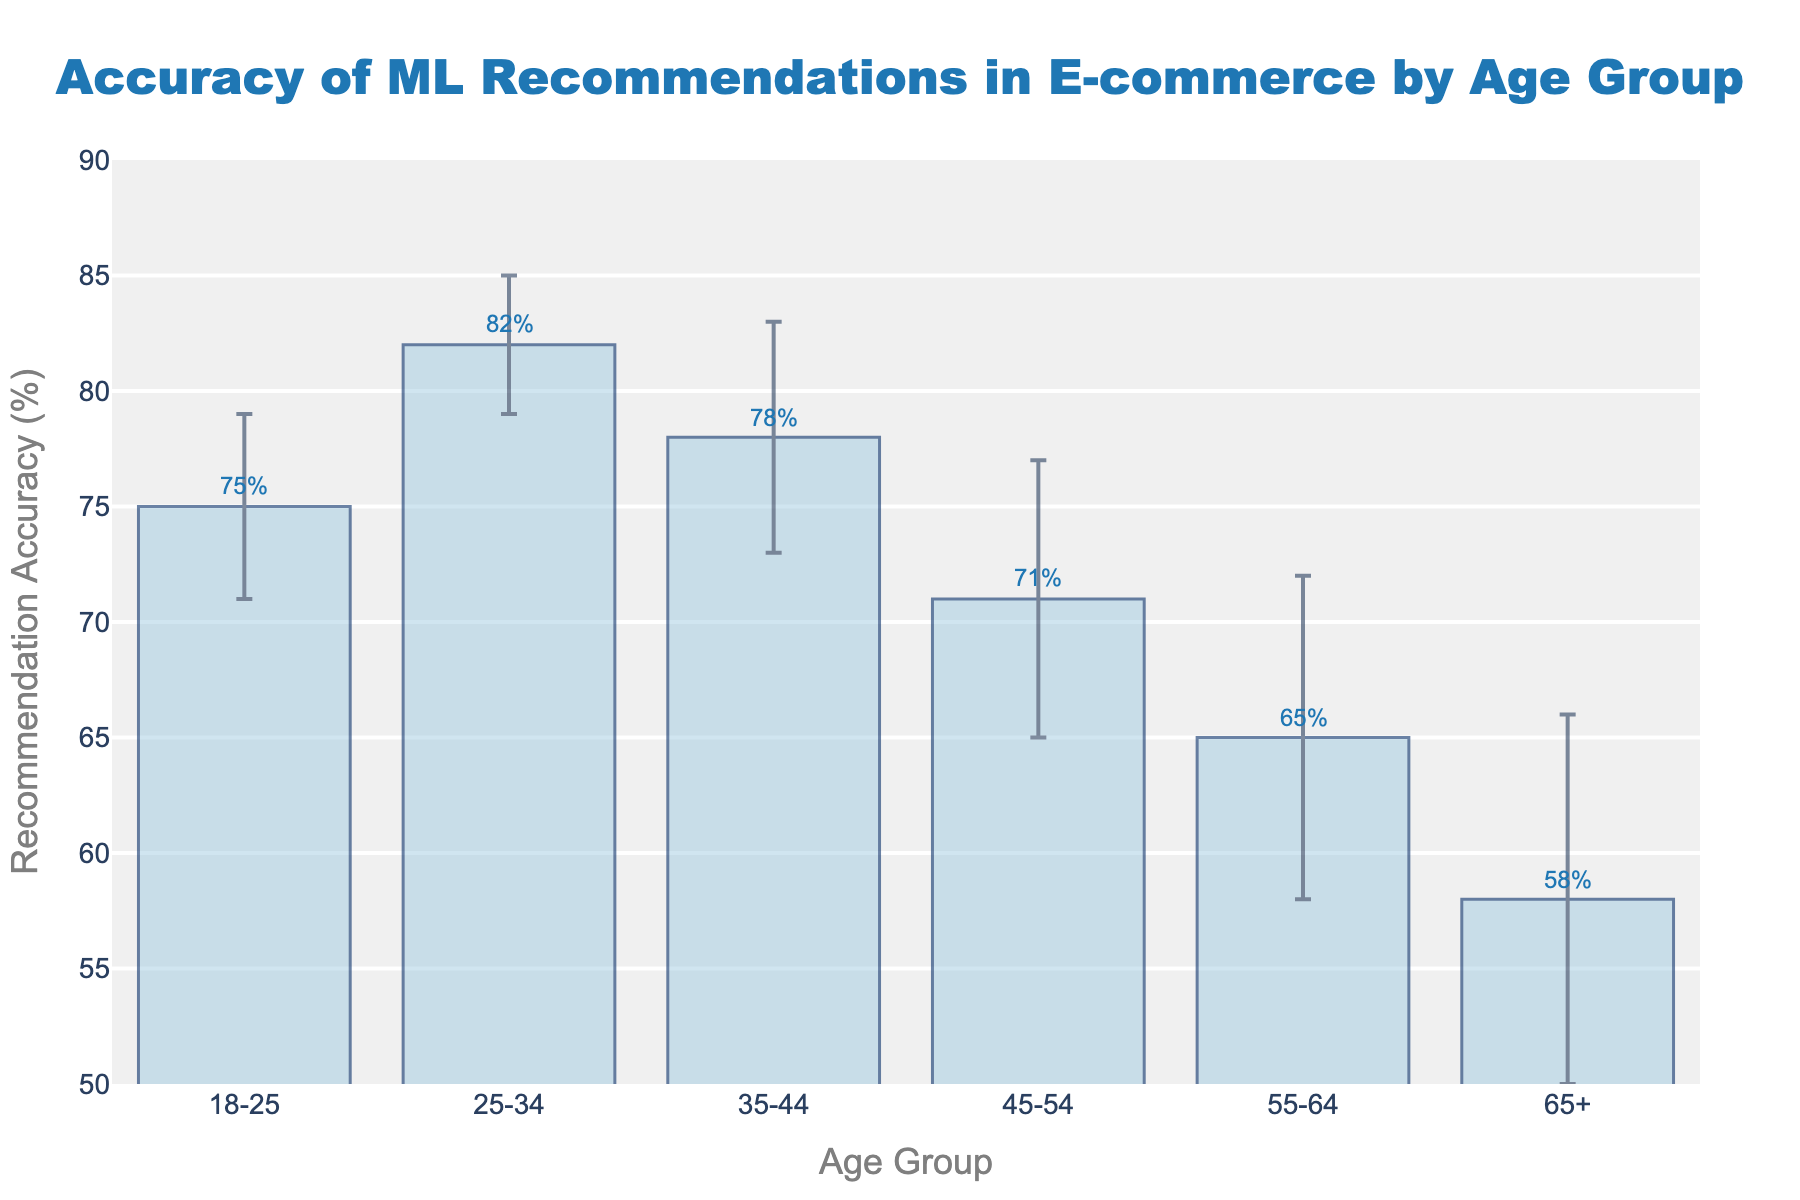What's the title of the figure? The title is clearly displayed at the top of the figure in a large font size, and it reads "Accuracy of ML Recommendations in E-commerce by Age Group."
Answer: Accuracy of ML Recommendations in E-commerce by Age Group Which age group has the highest recommendation accuracy? By looking at the heights of the bars, the age group with the highest bar represents the group with the highest accuracy. The bar for the age group 25-34 is the tallest, indicating the highest accuracy.
Answer: 25-34 What is the recommendation accuracy for the age group 55-64? Locate the bar corresponding to the age group 55-64. The annotation or the bar height indicates the value, which is mentioned directly as 65%.
Answer: 65% Which age group has the largest error margin? The error margin is shown by the length of the error bars above and below the bars. The age group 65+ has the longest error bars, indicating the largest error margin of 8.
Answer: 65+ What is the difference in recommendation accuracy between the age groups 35-44 and 45-54? Find the recommendation accuracies for both age groups, which are 78% for 35-44 and 71% for 45-54, and compute their difference: 78% - 71% = 7%.
Answer: 7% What is the sum of recommendation accuracies for all age groups? Sum the recommendation accuracy values for all the age groups (75 + 82 + 78 + 71 + 65 + 58) = 429.
Answer: 429 Compare the recommendation accuracy of the age groups 18-25 and 65+. Which is greater and by how much? The recommendation accuracy for 18-25 is 75%, while for 65+ it is 58%. The difference is 75% - 58% = 17%, so 18-25 is greater by 17%.
Answer: 18-25 by 17% What is the average recommendation accuracy across all age groups? Find the total sum of recommendation accuracies and divide by the number of age groups. The sum is 429, and there are 6 age groups. So, the average is 429 / 6 ≈ 71.5%.
Answer: 71.5% What are the error margins for the age group 25-34? The error margin for the age group 25-34 is depicted by the length of the error bars for that age group, which is specified as 3.
Answer: 3 Is the recommendation accuracy for the age group 45-54 more or less than the overall average accuracy? First find the overall average accuracy, which is 71.5%. Then compare it with the recommendation accuracy for 45-54, which is 71%. The accuracy for 45-54 is less than the overall average.
Answer: Less 